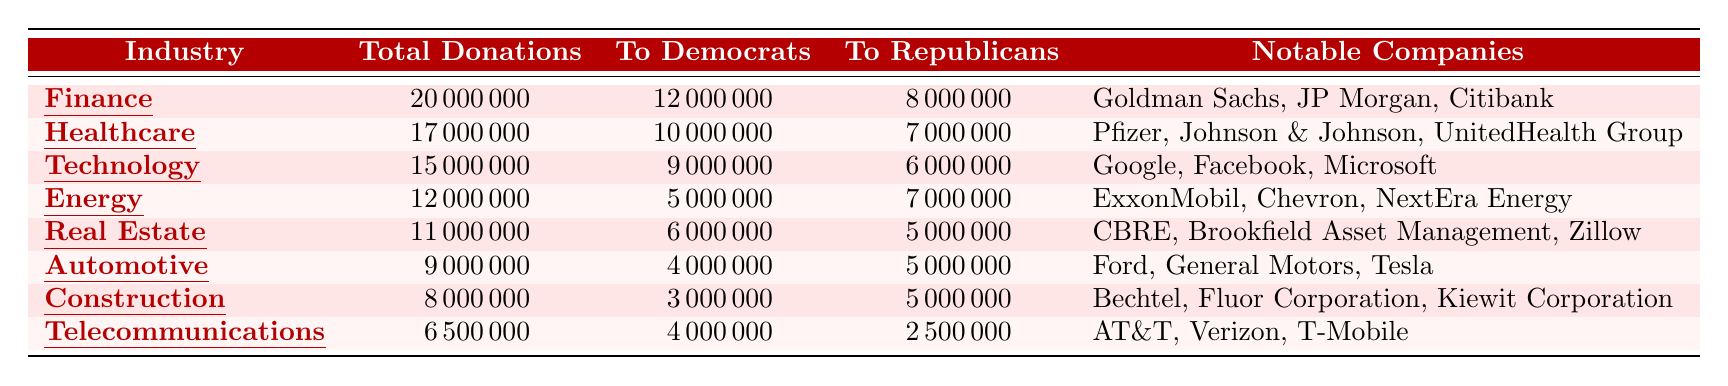What industry had the highest total donations? The table shows that the Finance industry had the highest total donations at 20,000,000.
Answer: Finance How much more did the Healthcare industry donate to Democrats compared to Republicans? The Healthcare industry donated 10,000,000 to Democrats and 7,000,000 to Republicans. The difference is 10,000,000 - 7,000,000 = 3,000,000.
Answer: 3,000,000 What percentage of the total donations from the Technology industry went to Republicans? The Technology industry had total donations of 15,000,000 and 6,000,000 went to Republicans. The percentage is calculated as (6,000,000 / 15,000,000) * 100 = 40%.
Answer: 40% Is it true that the Automotive industry donated more to Democrats than the Telecommunications industry? The Automotive industry donated 4,000,000 to Democrats while the Telecommunications industry donated 4,000,000 as well. Thus, it's false that Automotive donated more; they donated the same amount.
Answer: No What is the total amount of donations from the Energy and Construction industries combined? The Energy industry donated 12,000,000 and the Construction industry donated 8,000,000. The total is 12,000,000 + 8,000,000 = 20,000,000.
Answer: 20,000,000 Which industry had the lowest total donations, and how much was it? The Telecommunications industry had the lowest total donations at 6,500,000.
Answer: Telecommunications, 6,500,000 How many industries donated more than 8,000,000 total? The industries with total donations over 8,000,000 are Finance (20,000,000), Healthcare (17,000,000), Technology (15,000,000), Energy (12,000,000), Real Estate (11,000,000), and Automotive (9,000,000). There are 6 industries in total.
Answer: 6 What was the combined donation to Republicans from the Real Estate and Automotive industries? The Real Estate industry donated 5,000,000 and the Automotive industry donated 5,000,000 to Republicans. Their combined donations are 5,000,000 + 5,000,000 = 10,000,000.
Answer: 10,000,000 Which industry contributed more to Democrats than to Republicans, and what was the amount of difference? The Finance (12,000,000 to Democrats vs. 8,000,000 to Republicans) and Healthcare (10,000,000 to Democrats vs. 7,000,000 to Republicans) industries donated more to Democrats. The difference for Finance is 12,000,000 - 8,000,000 = 4,000,000 and for Healthcare is 10,000,000 - 7,000,000 = 3,000,000. Both industries contributed more to Democrats.
Answer: Finance, 4,000,000; Healthcare, 3,000,000 What is the average total donation across all the industries listed? To find the average, sum all total donations: 20,000,000 + 17,000,000 + 15,000,000 + 12,000,000 + 11,000,000 + 9,000,000 + 8,000,000 + 6,500,000 = 98,500,000. There are 8 industries, so the average is 98,500,000 / 8 = 12,312,500.
Answer: 12,312,500 